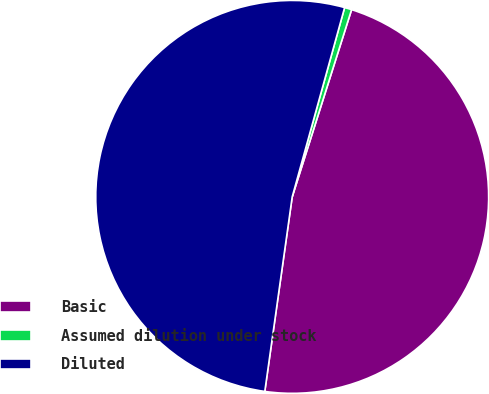<chart> <loc_0><loc_0><loc_500><loc_500><pie_chart><fcel>Basic<fcel>Assumed dilution under stock<fcel>Diluted<nl><fcel>47.34%<fcel>0.59%<fcel>52.07%<nl></chart> 